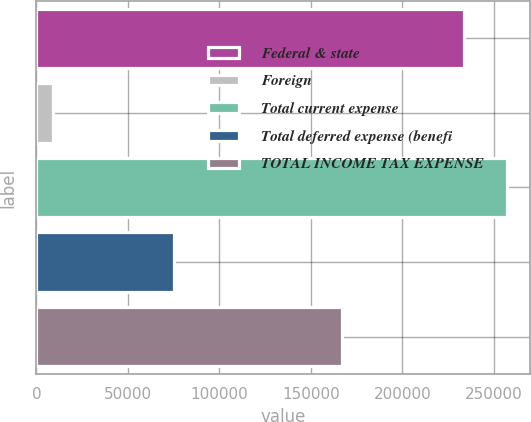Convert chart to OTSL. <chart><loc_0><loc_0><loc_500><loc_500><bar_chart><fcel>Federal & state<fcel>Foreign<fcel>Total current expense<fcel>Total deferred expense (benefi<fcel>TOTAL INCOME TAX EXPENSE<nl><fcel>233576<fcel>8970<fcel>256934<fcel>75375<fcel>167171<nl></chart> 